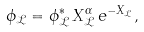Convert formula to latex. <formula><loc_0><loc_0><loc_500><loc_500>\phi _ { \mathcal { L } } = \phi _ { \mathcal { L } } ^ { * } \, X _ { \mathcal { L } } ^ { \alpha } \, e ^ { - X _ { \mathcal { L } } } ,</formula> 